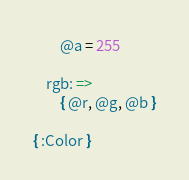<code> <loc_0><loc_0><loc_500><loc_500><_MoonScript_>		@a = 255

	rgb: =>
		{ @r, @g, @b }

{ :Color }
</code> 